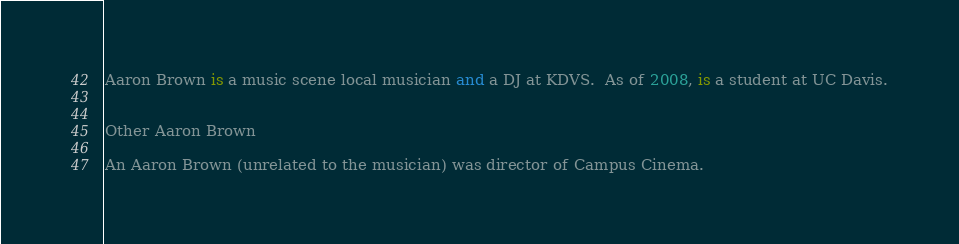<code> <loc_0><loc_0><loc_500><loc_500><_FORTRAN_>


Aaron Brown is a music scene local musician and a DJ at KDVS.  As of 2008, is a student at UC Davis.


Other Aaron Brown

An Aaron Brown (unrelated to the musician) was director of Campus Cinema.
</code> 